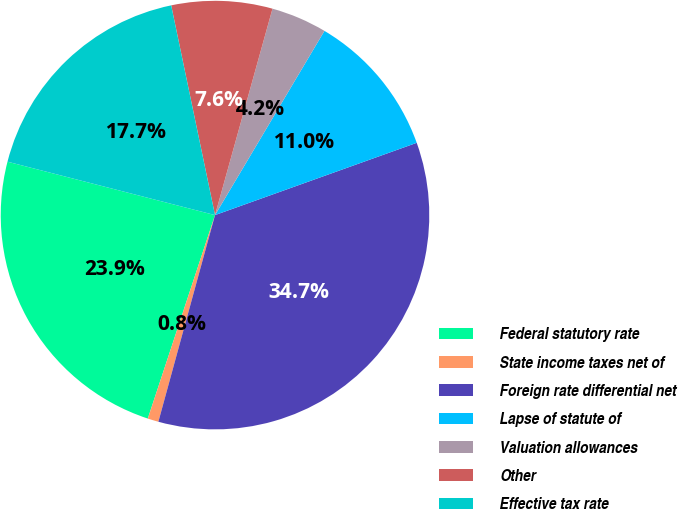Convert chart to OTSL. <chart><loc_0><loc_0><loc_500><loc_500><pie_chart><fcel>Federal statutory rate<fcel>State income taxes net of<fcel>Foreign rate differential net<fcel>Lapse of statute of<fcel>Valuation allowances<fcel>Other<fcel>Effective tax rate<nl><fcel>23.93%<fcel>0.82%<fcel>34.73%<fcel>10.99%<fcel>4.21%<fcel>7.6%<fcel>17.71%<nl></chart> 